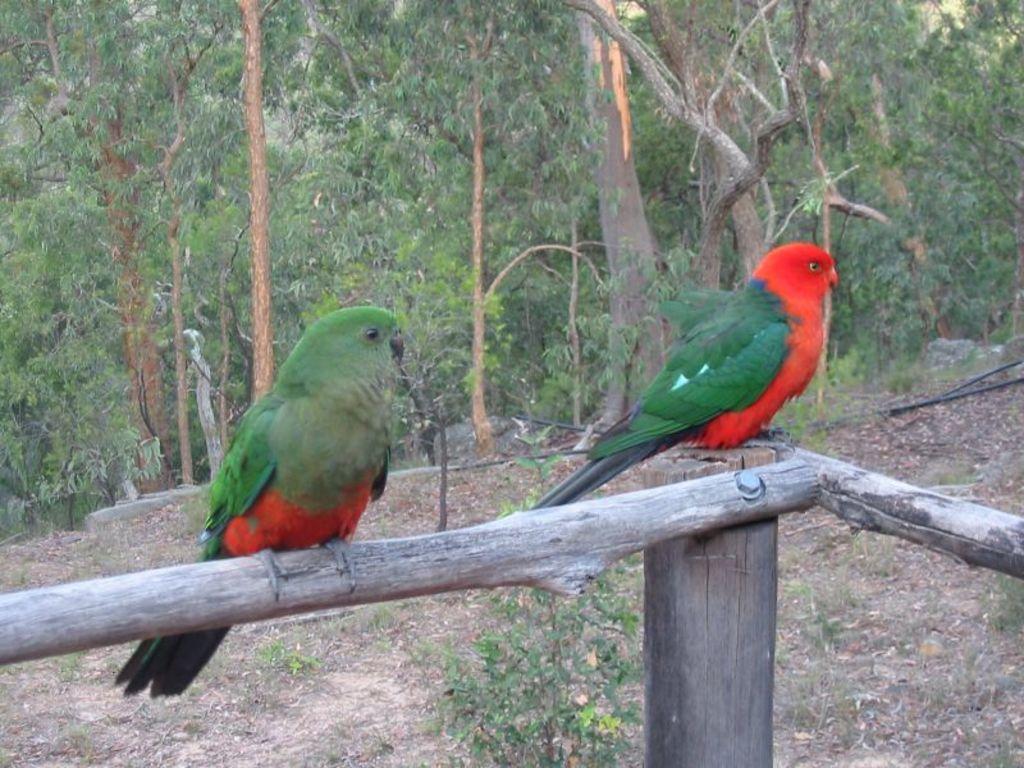In one or two sentences, can you explain what this image depicts? In this picture there are parrots on wooden poles and we can see plants. In the background of the image we can see trees. 